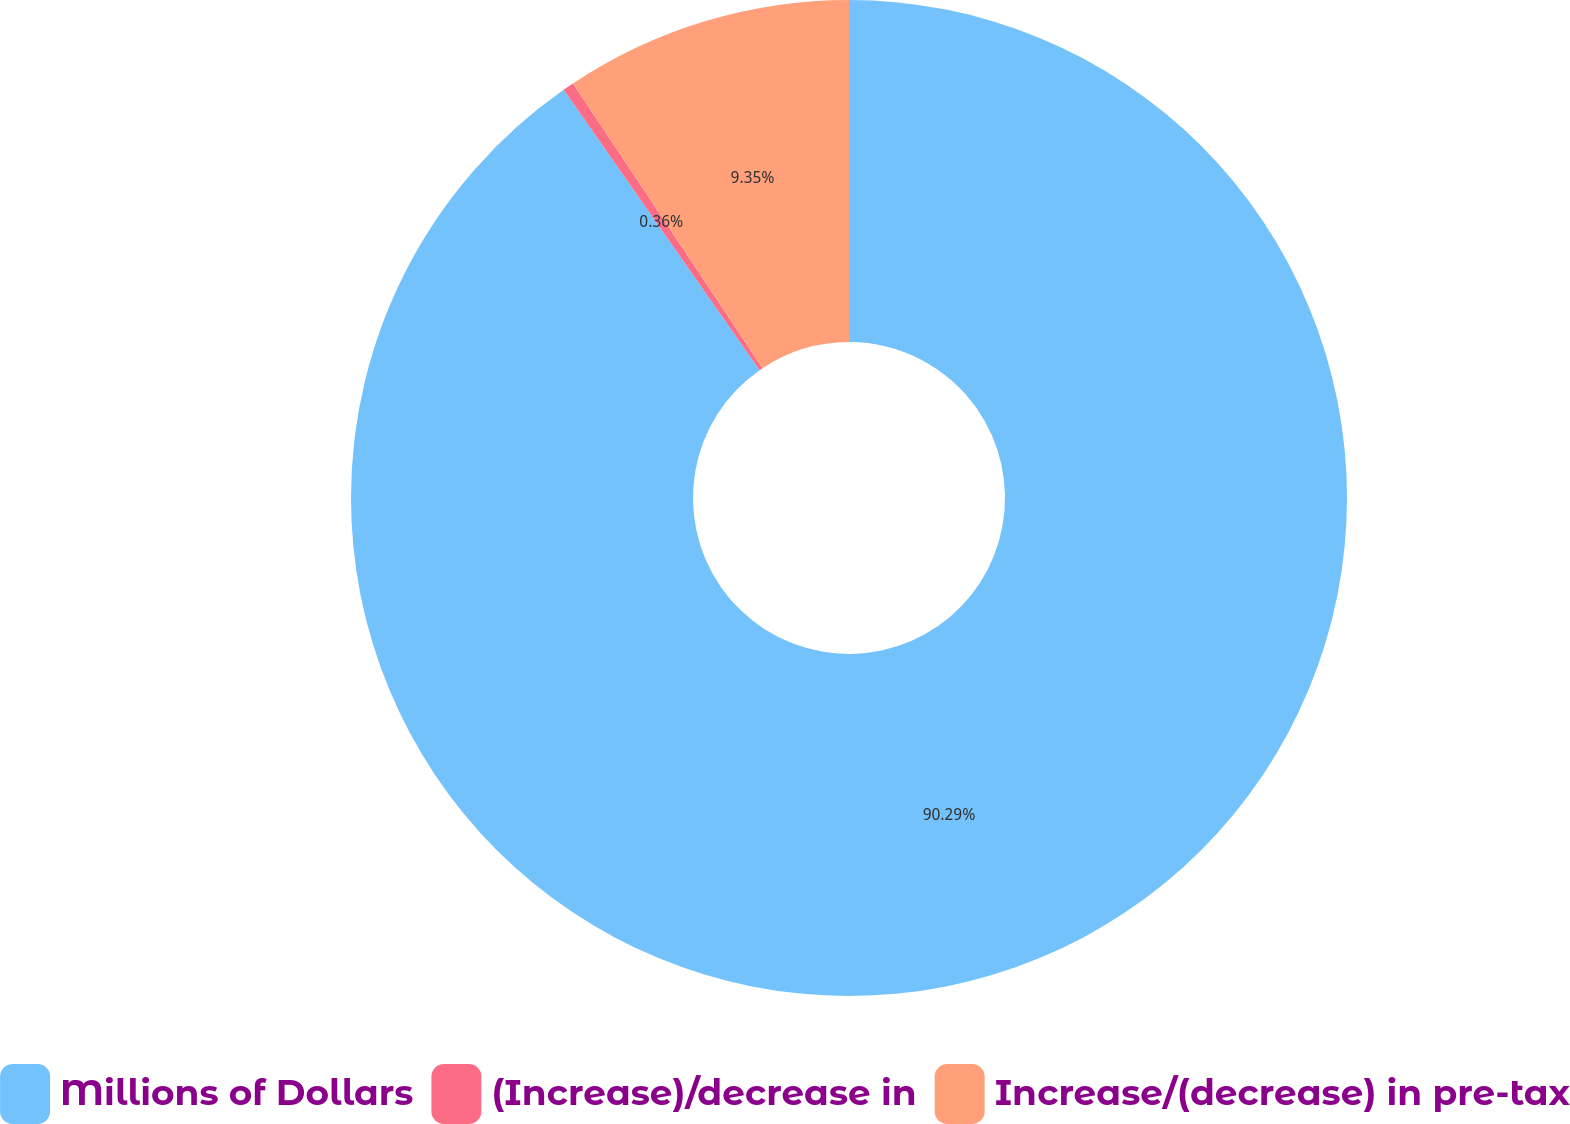Convert chart to OTSL. <chart><loc_0><loc_0><loc_500><loc_500><pie_chart><fcel>Millions of Dollars<fcel>(Increase)/decrease in<fcel>Increase/(decrease) in pre-tax<nl><fcel>90.29%<fcel>0.36%<fcel>9.35%<nl></chart> 